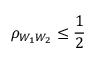Convert formula to latex. <formula><loc_0><loc_0><loc_500><loc_500>\rho _ { W _ { 1 } W _ { 2 } } \leq \frac { 1 } { 2 }</formula> 